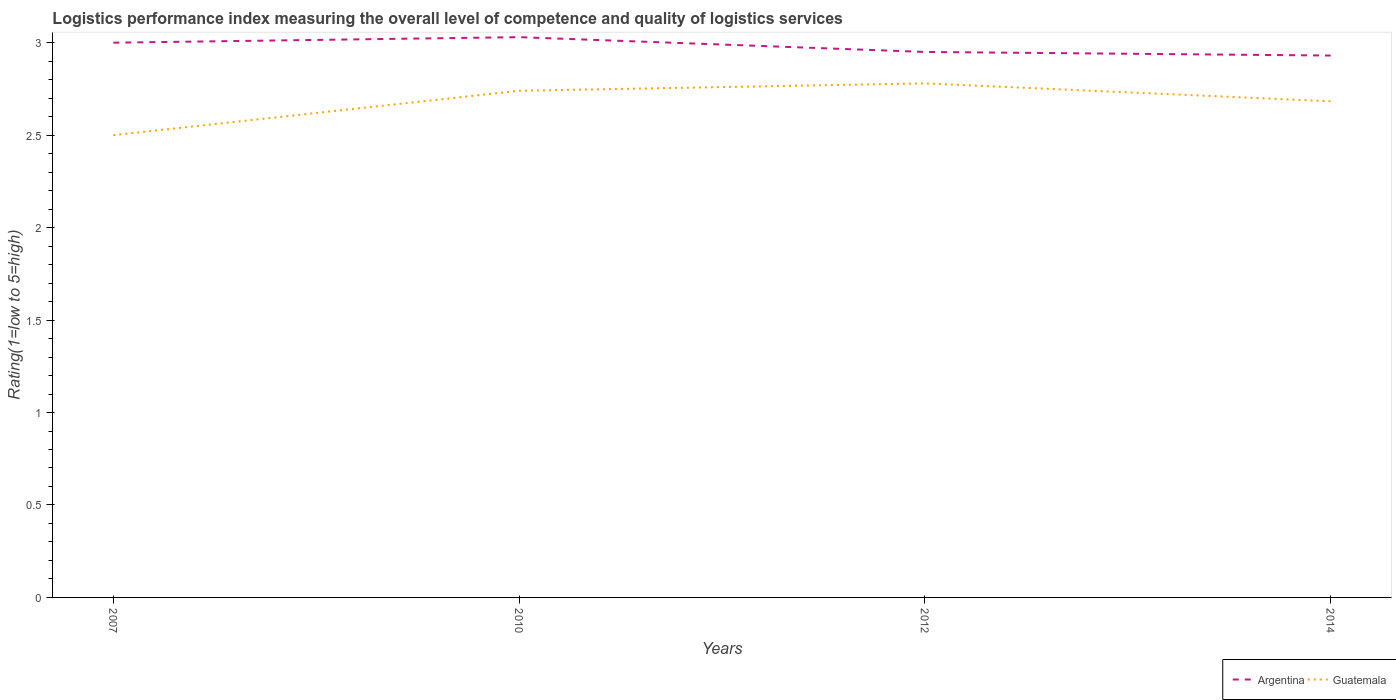Is the number of lines equal to the number of legend labels?
Your answer should be compact. Yes. Across all years, what is the maximum Logistic performance index in Argentina?
Your answer should be compact. 2.93. What is the total Logistic performance index in Guatemala in the graph?
Your answer should be very brief. -0.04. What is the difference between the highest and the second highest Logistic performance index in Argentina?
Keep it short and to the point. 0.1. What is the difference between the highest and the lowest Logistic performance index in Argentina?
Provide a short and direct response. 2. Is the Logistic performance index in Guatemala strictly greater than the Logistic performance index in Argentina over the years?
Offer a very short reply. Yes. What is the difference between two consecutive major ticks on the Y-axis?
Provide a short and direct response. 0.5. Are the values on the major ticks of Y-axis written in scientific E-notation?
Offer a terse response. No. Does the graph contain any zero values?
Keep it short and to the point. No. Does the graph contain grids?
Offer a terse response. No. Where does the legend appear in the graph?
Your response must be concise. Bottom right. How are the legend labels stacked?
Provide a succinct answer. Horizontal. What is the title of the graph?
Provide a succinct answer. Logistics performance index measuring the overall level of competence and quality of logistics services. Does "Pakistan" appear as one of the legend labels in the graph?
Your answer should be very brief. No. What is the label or title of the X-axis?
Offer a terse response. Years. What is the label or title of the Y-axis?
Offer a very short reply. Rating(1=low to 5=high). What is the Rating(1=low to 5=high) of Argentina in 2010?
Keep it short and to the point. 3.03. What is the Rating(1=low to 5=high) in Guatemala in 2010?
Offer a very short reply. 2.74. What is the Rating(1=low to 5=high) in Argentina in 2012?
Offer a very short reply. 2.95. What is the Rating(1=low to 5=high) of Guatemala in 2012?
Give a very brief answer. 2.78. What is the Rating(1=low to 5=high) in Argentina in 2014?
Offer a very short reply. 2.93. What is the Rating(1=low to 5=high) in Guatemala in 2014?
Your response must be concise. 2.68. Across all years, what is the maximum Rating(1=low to 5=high) in Argentina?
Ensure brevity in your answer.  3.03. Across all years, what is the maximum Rating(1=low to 5=high) in Guatemala?
Make the answer very short. 2.78. Across all years, what is the minimum Rating(1=low to 5=high) in Argentina?
Provide a short and direct response. 2.93. What is the total Rating(1=low to 5=high) of Argentina in the graph?
Your answer should be very brief. 11.91. What is the total Rating(1=low to 5=high) in Guatemala in the graph?
Make the answer very short. 10.7. What is the difference between the Rating(1=low to 5=high) of Argentina in 2007 and that in 2010?
Keep it short and to the point. -0.03. What is the difference between the Rating(1=low to 5=high) in Guatemala in 2007 and that in 2010?
Your answer should be compact. -0.24. What is the difference between the Rating(1=low to 5=high) in Argentina in 2007 and that in 2012?
Your response must be concise. 0.05. What is the difference between the Rating(1=low to 5=high) in Guatemala in 2007 and that in 2012?
Your response must be concise. -0.28. What is the difference between the Rating(1=low to 5=high) of Argentina in 2007 and that in 2014?
Offer a terse response. 0.07. What is the difference between the Rating(1=low to 5=high) in Guatemala in 2007 and that in 2014?
Your answer should be very brief. -0.18. What is the difference between the Rating(1=low to 5=high) of Guatemala in 2010 and that in 2012?
Make the answer very short. -0.04. What is the difference between the Rating(1=low to 5=high) of Argentina in 2010 and that in 2014?
Provide a short and direct response. 0.1. What is the difference between the Rating(1=low to 5=high) of Guatemala in 2010 and that in 2014?
Make the answer very short. 0.06. What is the difference between the Rating(1=low to 5=high) in Argentina in 2012 and that in 2014?
Ensure brevity in your answer.  0.02. What is the difference between the Rating(1=low to 5=high) in Guatemala in 2012 and that in 2014?
Your answer should be compact. 0.1. What is the difference between the Rating(1=low to 5=high) in Argentina in 2007 and the Rating(1=low to 5=high) in Guatemala in 2010?
Offer a terse response. 0.26. What is the difference between the Rating(1=low to 5=high) of Argentina in 2007 and the Rating(1=low to 5=high) of Guatemala in 2012?
Offer a very short reply. 0.22. What is the difference between the Rating(1=low to 5=high) of Argentina in 2007 and the Rating(1=low to 5=high) of Guatemala in 2014?
Offer a terse response. 0.32. What is the difference between the Rating(1=low to 5=high) of Argentina in 2010 and the Rating(1=low to 5=high) of Guatemala in 2014?
Provide a short and direct response. 0.35. What is the difference between the Rating(1=low to 5=high) of Argentina in 2012 and the Rating(1=low to 5=high) of Guatemala in 2014?
Offer a very short reply. 0.27. What is the average Rating(1=low to 5=high) of Argentina per year?
Your answer should be very brief. 2.98. What is the average Rating(1=low to 5=high) in Guatemala per year?
Offer a terse response. 2.68. In the year 2010, what is the difference between the Rating(1=low to 5=high) in Argentina and Rating(1=low to 5=high) in Guatemala?
Provide a succinct answer. 0.29. In the year 2012, what is the difference between the Rating(1=low to 5=high) in Argentina and Rating(1=low to 5=high) in Guatemala?
Keep it short and to the point. 0.17. In the year 2014, what is the difference between the Rating(1=low to 5=high) in Argentina and Rating(1=low to 5=high) in Guatemala?
Offer a terse response. 0.25. What is the ratio of the Rating(1=low to 5=high) in Argentina in 2007 to that in 2010?
Ensure brevity in your answer.  0.99. What is the ratio of the Rating(1=low to 5=high) in Guatemala in 2007 to that in 2010?
Keep it short and to the point. 0.91. What is the ratio of the Rating(1=low to 5=high) of Argentina in 2007 to that in 2012?
Give a very brief answer. 1.02. What is the ratio of the Rating(1=low to 5=high) in Guatemala in 2007 to that in 2012?
Offer a terse response. 0.9. What is the ratio of the Rating(1=low to 5=high) in Argentina in 2007 to that in 2014?
Provide a short and direct response. 1.02. What is the ratio of the Rating(1=low to 5=high) of Guatemala in 2007 to that in 2014?
Ensure brevity in your answer.  0.93. What is the ratio of the Rating(1=low to 5=high) in Argentina in 2010 to that in 2012?
Your response must be concise. 1.03. What is the ratio of the Rating(1=low to 5=high) in Guatemala in 2010 to that in 2012?
Provide a succinct answer. 0.99. What is the ratio of the Rating(1=low to 5=high) in Argentina in 2010 to that in 2014?
Provide a short and direct response. 1.03. What is the ratio of the Rating(1=low to 5=high) of Guatemala in 2010 to that in 2014?
Keep it short and to the point. 1.02. What is the ratio of the Rating(1=low to 5=high) of Argentina in 2012 to that in 2014?
Make the answer very short. 1.01. What is the ratio of the Rating(1=low to 5=high) in Guatemala in 2012 to that in 2014?
Keep it short and to the point. 1.04. What is the difference between the highest and the second highest Rating(1=low to 5=high) of Guatemala?
Give a very brief answer. 0.04. What is the difference between the highest and the lowest Rating(1=low to 5=high) in Argentina?
Ensure brevity in your answer.  0.1. What is the difference between the highest and the lowest Rating(1=low to 5=high) of Guatemala?
Ensure brevity in your answer.  0.28. 